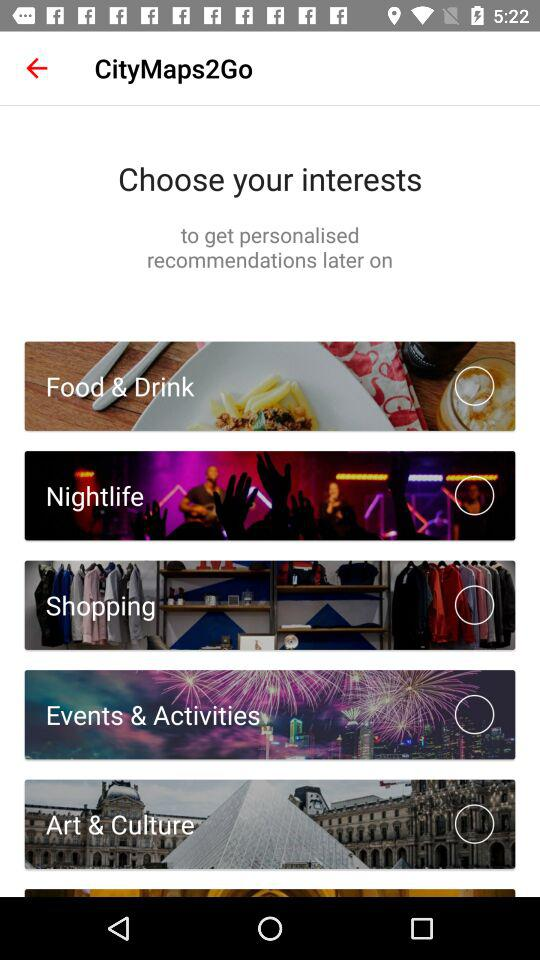How many options are there for the user to choose from?
Answer the question using a single word or phrase. 6 